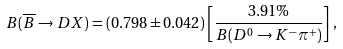<formula> <loc_0><loc_0><loc_500><loc_500>B ( \overline { B } \rightarrow D X ) = ( 0 . 7 9 8 \pm 0 . 0 4 2 ) \left [ \frac { 3 . 9 1 \% } { B ( D ^ { 0 } \rightarrow K ^ { - } \pi ^ { + } ) } \right ] \, ,</formula> 